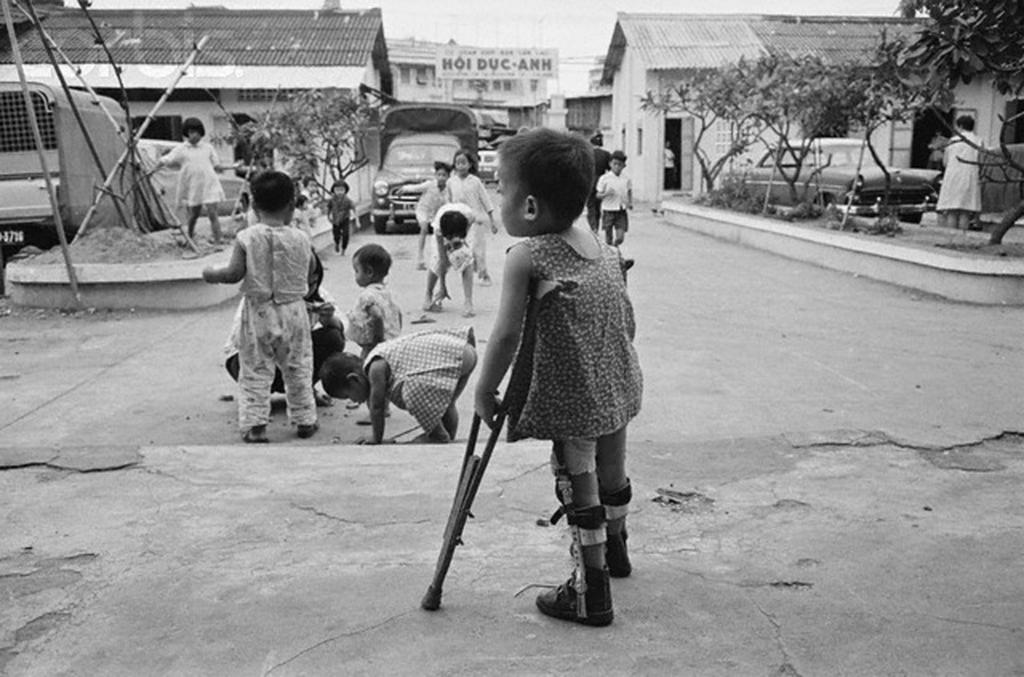What can be seen on the road in the image? There are people on the road in the image. What type of structures are visible in the image? There are houses visible in the image. What natural elements can be seen in the image? There are trees in the image. What else is present on the road in the image? There are vehicles in the image. Can you tell me where the volcano is located in the image? There is no volcano present in the image. What point is being made by the people in the image? The image does not convey a specific point or message, so it is not possible to answer this question. 